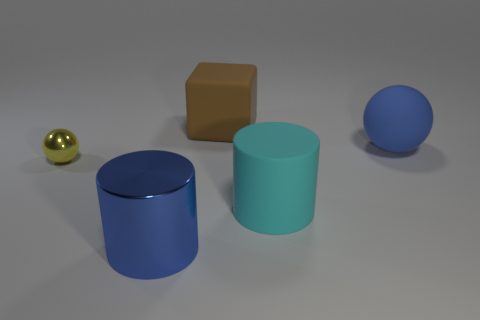There is a object that is the same color as the big rubber ball; what is its shape?
Your answer should be very brief. Cylinder. Is the blue thing in front of the shiny sphere made of the same material as the big cube?
Your answer should be compact. No. The matte thing that is the same shape as the small yellow metallic thing is what color?
Your answer should be compact. Blue. Are there any other things that have the same shape as the tiny thing?
Offer a terse response. Yes. Are there an equal number of rubber cubes in front of the blue metal thing and small brown cubes?
Ensure brevity in your answer.  Yes. Are there any spheres behind the brown rubber thing?
Provide a succinct answer. No. There is a ball that is behind the ball to the left of the large matte object behind the blue matte ball; what size is it?
Provide a short and direct response. Large. There is a large blue object in front of the small thing; is its shape the same as the big matte thing in front of the blue sphere?
Your answer should be compact. Yes. There is another object that is the same shape as the tiny yellow shiny object; what is its size?
Ensure brevity in your answer.  Large. What number of brown cylinders are made of the same material as the big cyan cylinder?
Keep it short and to the point. 0. 